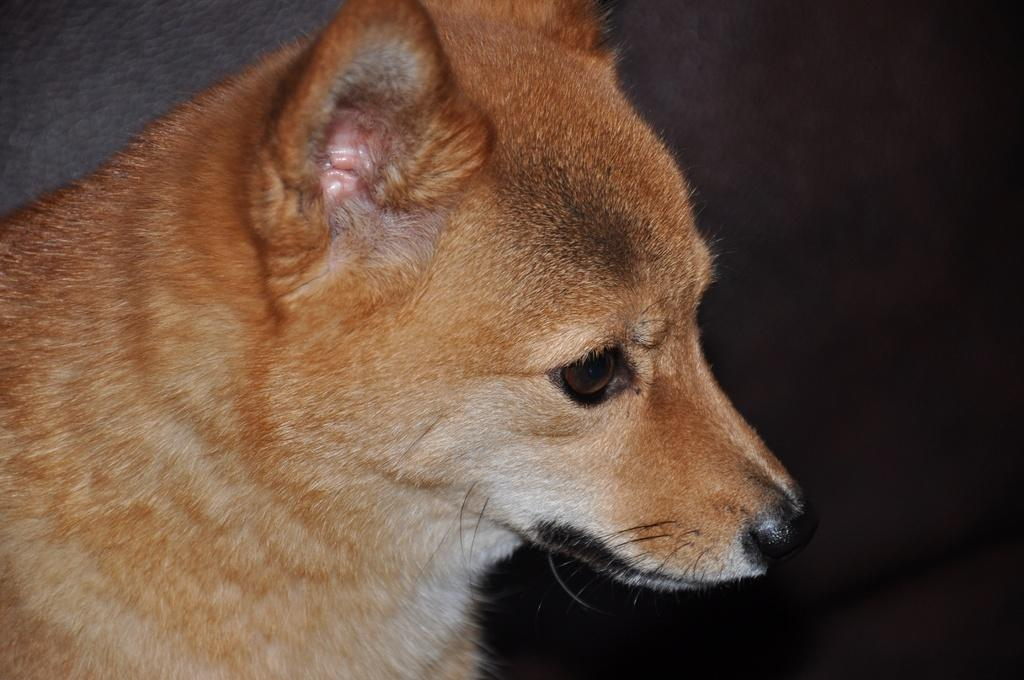What is the main subject in the foreground of the image? There is a dog in the foreground of the image. What type of list can be seen hanging on the wall behind the dog in the image? There is no list present in the image; it only features a dog in the foreground. 